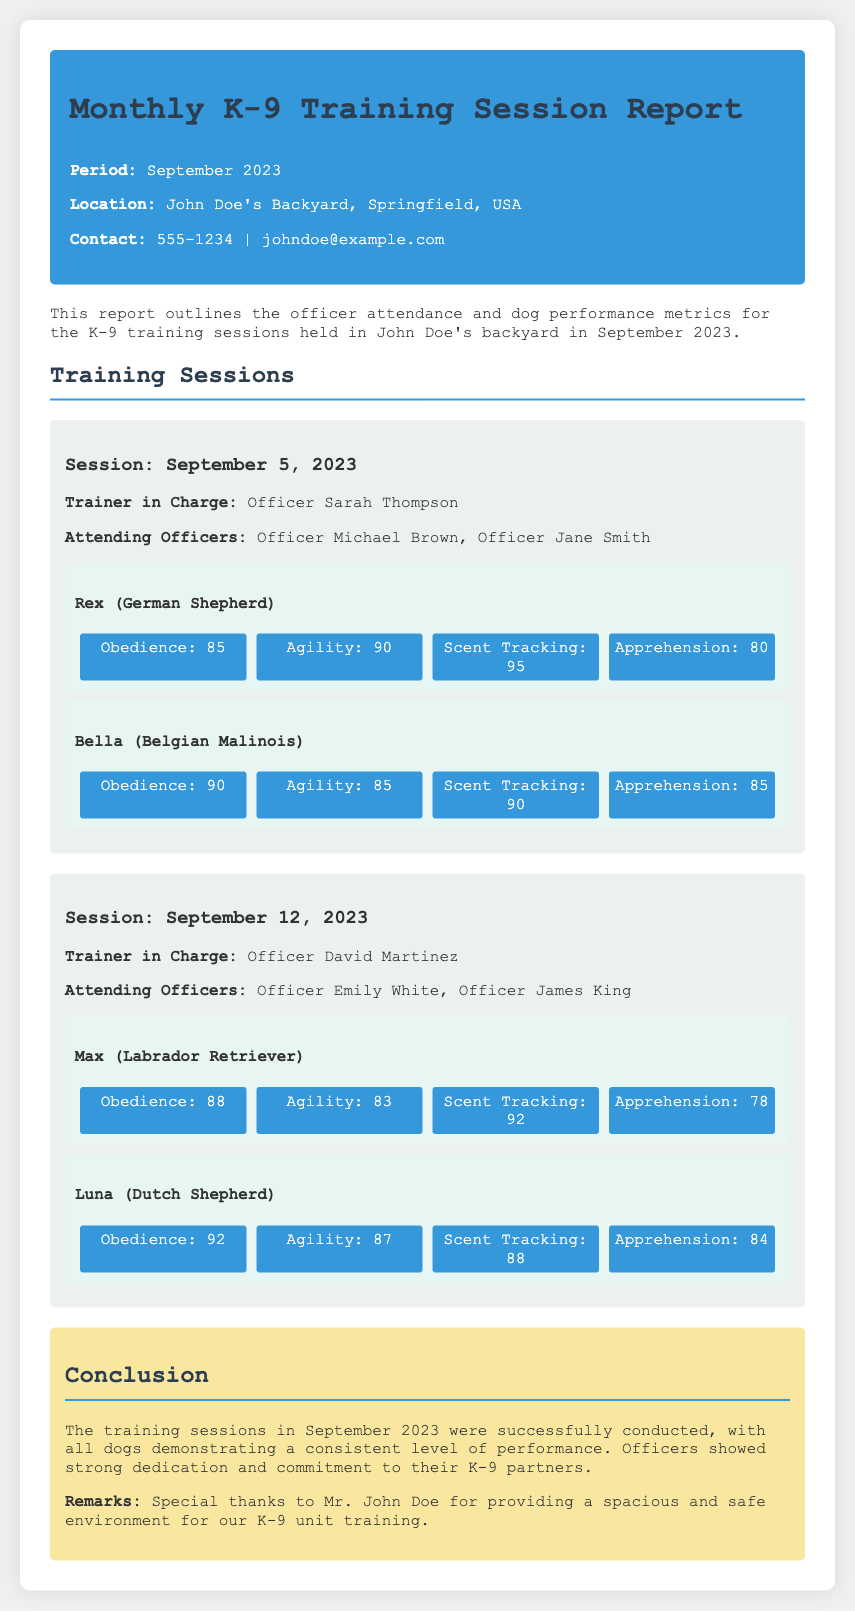What is the period covered in the report? The report details the K-9 training sessions held during the month of September 2023.
Answer: September 2023 Who was the trainer in charge on September 5, 2023? The trainer in charge for the training session on September 5, 2023, was Officer Sarah Thompson.
Answer: Officer Sarah Thompson What is the attendance of officers on September 12, 2023? The attending officers on this date were Officer Emily White and Officer James King.
Answer: Officer Emily White, Officer James King Which dog had the highest Scent Tracking score in the report? The metrics show that Rex achieved a Scent Tracking score of 95, which is the highest among the dogs listed.
Answer: Rex What was the average Apprehension score of all dogs trained in September? The Apprehension scores are 80 (Rex), 85 (Bella), 78 (Max), and 84 (Luna). The average is (80 + 85 + 78 + 84) / 4 = 82.25.
Answer: 82.25 Who provided the training environment? The report expresses special thanks to Mr. John Doe for providing the training environment.
Answer: Mr. John Doe What were Bella's Agility metrics? Bella's Agility score was measured at 85 according to the metrics.
Answer: 85 How many training sessions are reported for September 2023? The document details two training sessions conducted in September.
Answer: Two 